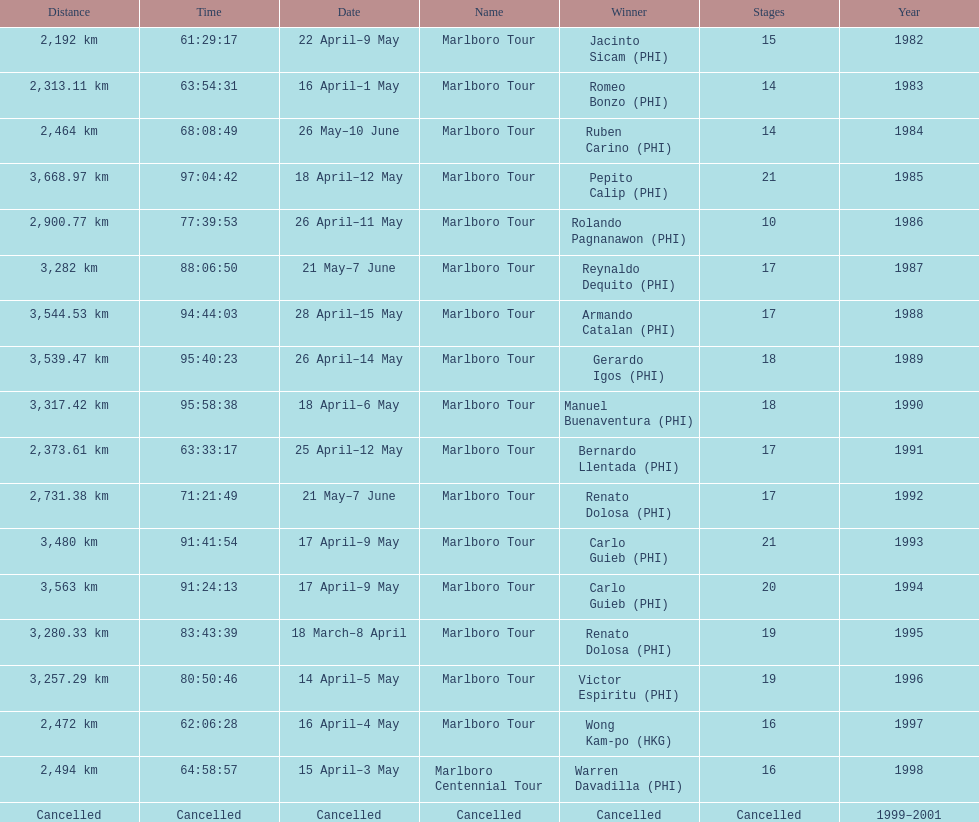Who is listed below romeo bonzo? Ruben Carino (PHI). 